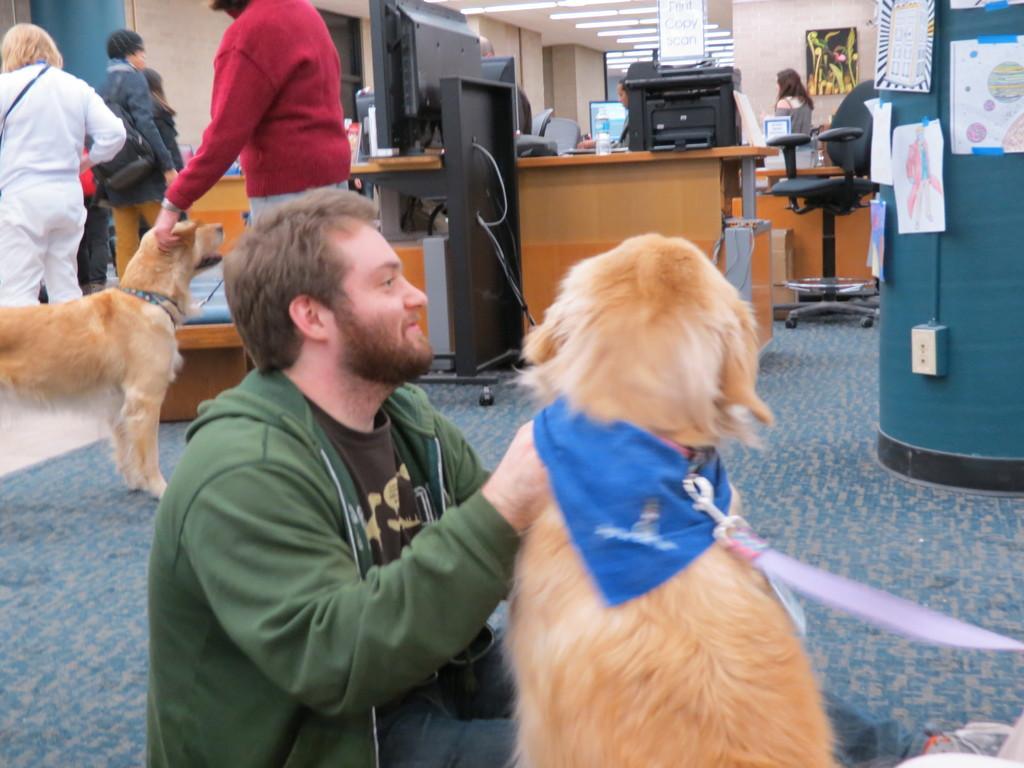Describe this image in one or two sentences. In this image i can see a person sitting and holding a dog. In the background i can see few people standing and a person holding a dog and also few monitors, a chair, a desk and a post box. 